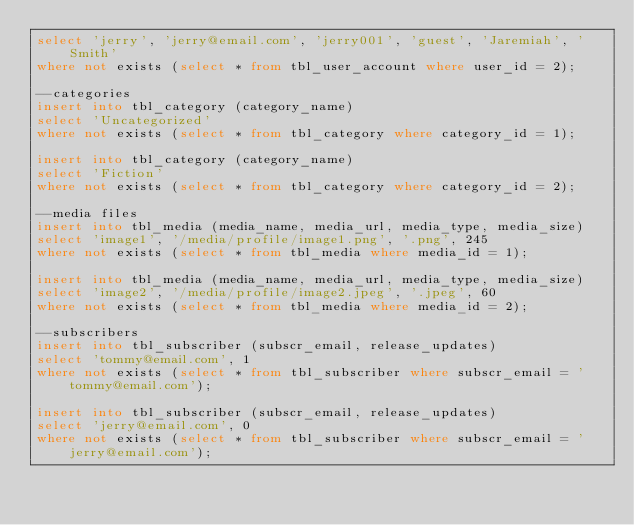<code> <loc_0><loc_0><loc_500><loc_500><_SQL_>select 'jerry', 'jerry@email.com', 'jerry001', 'guest', 'Jaremiah', 'Smith'
where not exists (select * from tbl_user_account where user_id = 2);

--categories
insert into tbl_category (category_name)
select 'Uncategorized'
where not exists (select * from tbl_category where category_id = 1);

insert into tbl_category (category_name)
select 'Fiction'
where not exists (select * from tbl_category where category_id = 2);

--media files
insert into tbl_media (media_name, media_url, media_type, media_size)
select 'image1', '/media/profile/image1.png', '.png', 245
where not exists (select * from tbl_media where media_id = 1);

insert into tbl_media (media_name, media_url, media_type, media_size)
select 'image2', '/media/profile/image2.jpeg', '.jpeg', 60
where not exists (select * from tbl_media where media_id = 2);

--subscribers
insert into tbl_subscriber (subscr_email, release_updates)
select 'tommy@email.com', 1
where not exists (select * from tbl_subscriber where subscr_email = 'tommy@email.com');

insert into tbl_subscriber (subscr_email, release_updates)
select 'jerry@email.com', 0
where not exists (select * from tbl_subscriber where subscr_email = 'jerry@email.com');
</code> 